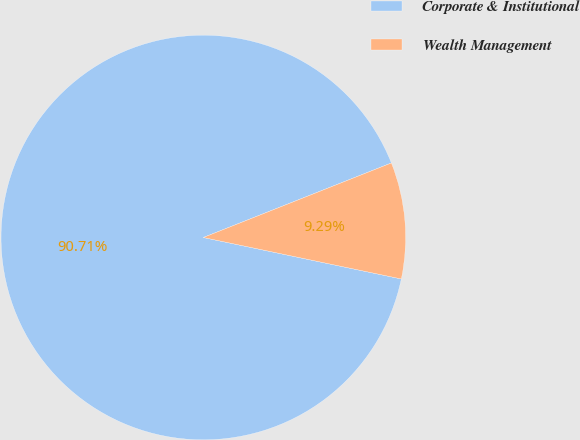Convert chart to OTSL. <chart><loc_0><loc_0><loc_500><loc_500><pie_chart><fcel>Corporate & Institutional<fcel>Wealth Management<nl><fcel>90.71%<fcel>9.29%<nl></chart> 